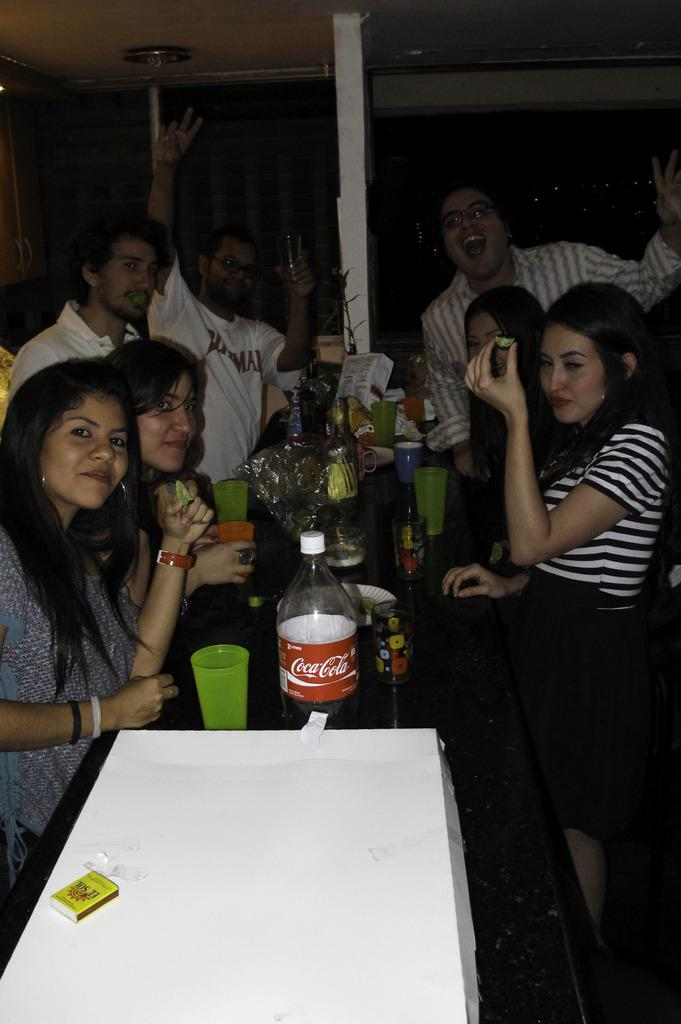How many people are standing near the table in the image? There are seven people standing near the table in the image. What is on the table in the image? There is a cake box, a matchbox, glasses, and a drink bottle on the table. What might be used for lighting a candle or starting a fire in the image? The matchbox on the table might be used for lighting a candle or starting a fire. What can be used for drinking in the image? The glasses and drink bottle on the table can be used for drinking. What type of suit is the person wearing in the image? There is no person wearing a suit in the image; the seven people standing near the table are not described as wearing suits. How does the slip affect the cake box on the table? There is no slip present in the image, so it cannot affect the cake box on the table. 